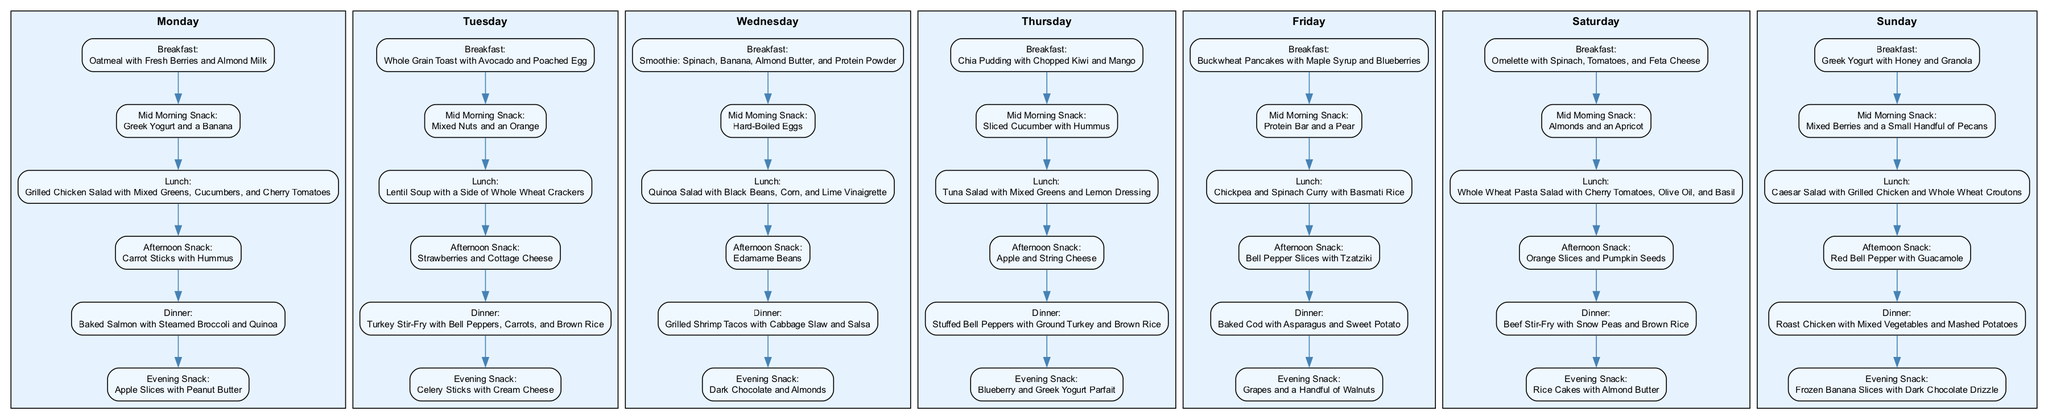What is the breakfast for Wednesday? The diagram shows that for Wednesday, the breakfast entry is "Smoothie: Spinach, Banana, Almond Butter, and Protein Powder." This meal is displayed prominently in the corresponding section for Wednesday.
Answer: Smoothie: Spinach, Banana, Almond Butter, and Protein Powder Which day features Tuna Salad for lunch? By examining the lunch meals of each day in the diagram, it can be identified that Tuna Salad is listed under Thursday. The corresponding node for Thursday’s lunch provides this information directly.
Answer: Thursday How many meals are listed for each day? The diagram indicates that there are six distinct meal types (breakfast, mid-morning snack, lunch, afternoon snack, dinner, and evening snack) for each day. Each day displays these six meal types clearly.
Answer: 6 What is the evening snack on Monday? The diagram specifies that the evening snack for Monday is "Apple Slices with Peanut Butter." This can be directly seen in the Monday section under the evening snack node.
Answer: Apple Slices with Peanut Butter Which meal is common at the same time on both Tuesday and Thursday? Looking at the mid-morning snacks for both Tuesday and Thursday, it indicates "Mixed Nuts and an Orange" for Tuesday and "Sliced Cucumber with Hummus" for Thursday. Therefore, there is no common meal at mid-morning on these days.
Answer: None What ingredient is included in the dinner on Friday? The dinner for Friday is "Baked Cod with Asparagus and Sweet Potato." By reviewing the specific dinner entry for Friday in the diagram, we determine these three ingredients are included.
Answer: Baked Cod, Asparagus, Sweet Potato What is the total number of snacks throughout the week? Each day has two snacks (afternoon and evening), leading to a total of 14 snacks over 7 days. The calculation can be derived by multiplying the number of days by the number of snacks per day.
Answer: 14 